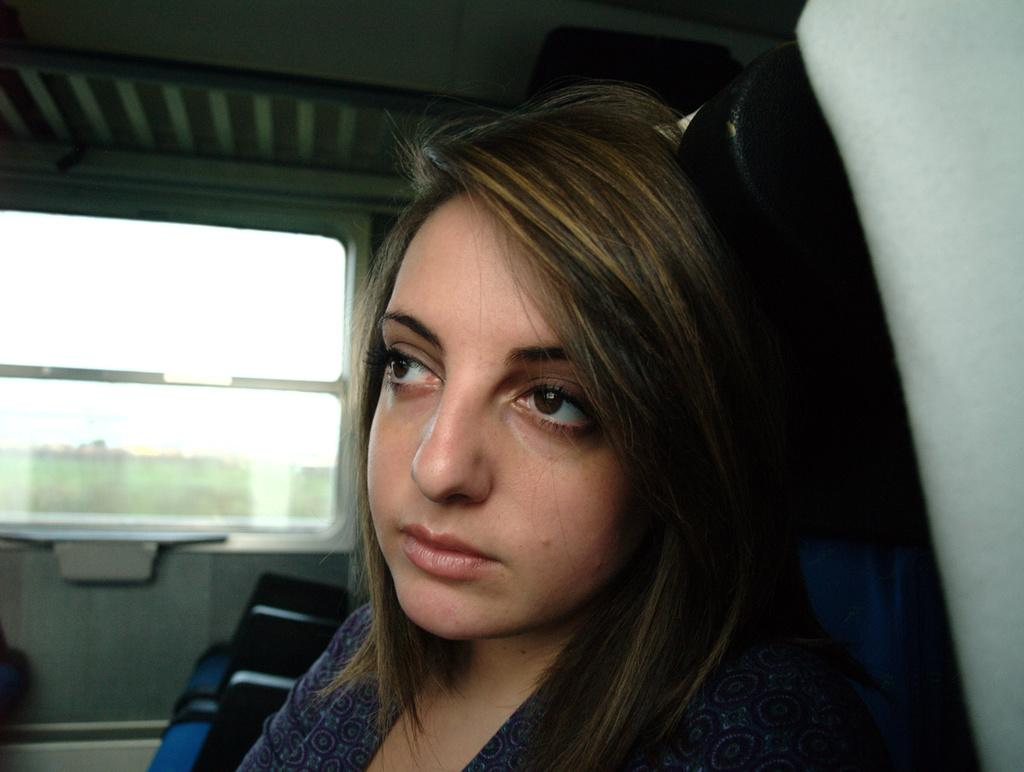Who is the main subject in the image? There is a woman in the middle of the image. What can be seen on the left side of the image? There is a glass window on the left side of the image. How many letters does the woman have in her possession in the image? There is no indication of any letters in the image, so it cannot be determined how many the woman might have. 